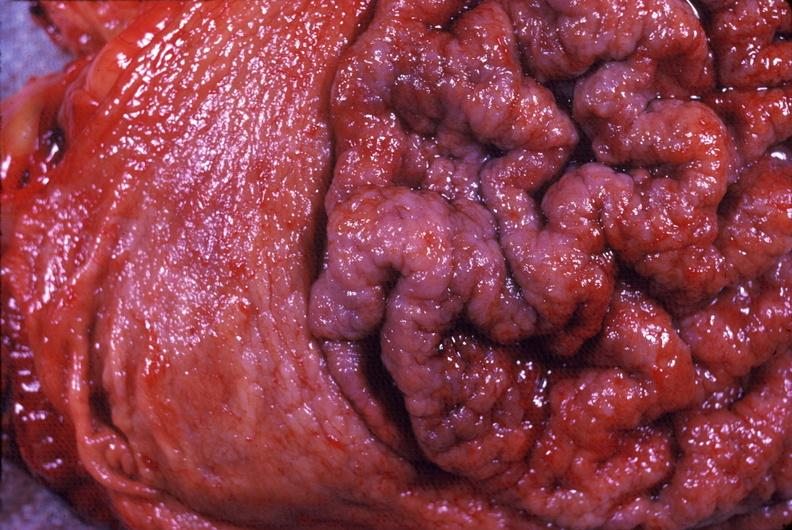does this image show stomach, giant rugose hypertrophy?
Answer the question using a single word or phrase. Yes 